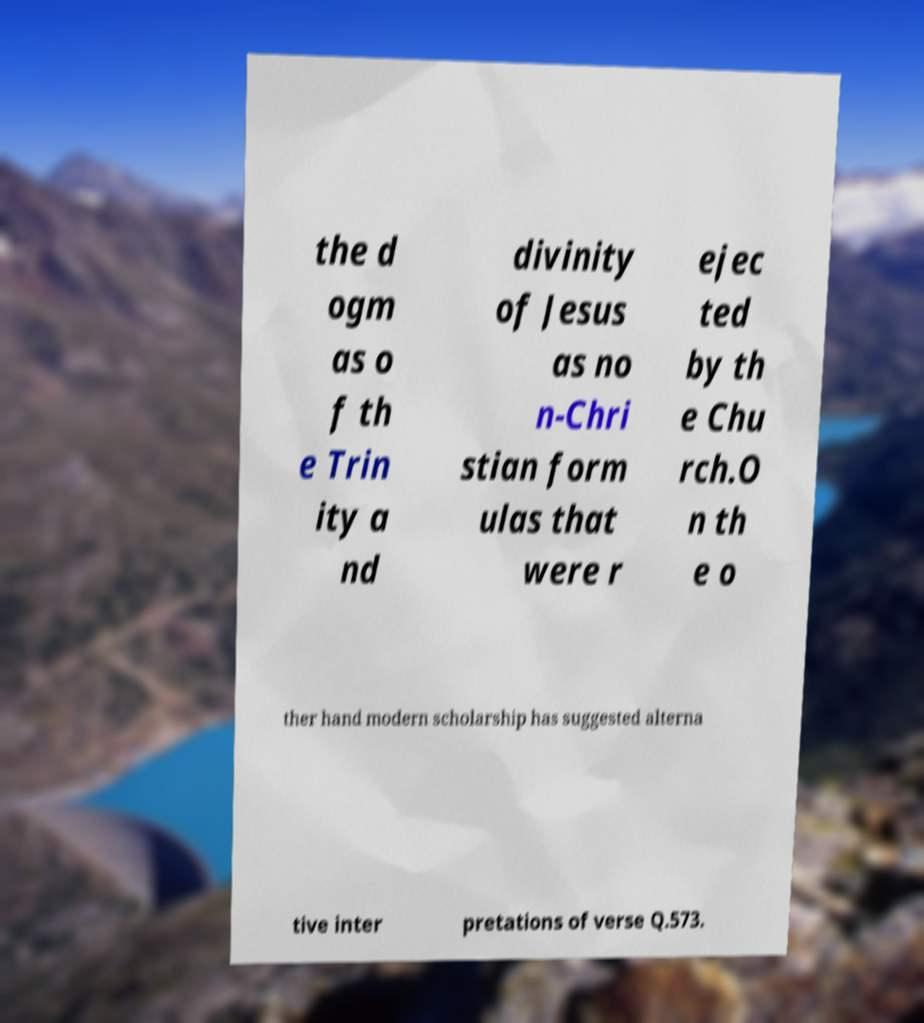I need the written content from this picture converted into text. Can you do that? the d ogm as o f th e Trin ity a nd divinity of Jesus as no n-Chri stian form ulas that were r ejec ted by th e Chu rch.O n th e o ther hand modern scholarship has suggested alterna tive inter pretations of verse Q.573. 